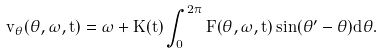<formula> <loc_0><loc_0><loc_500><loc_500>v _ { \theta } ( \theta , \omega , t ) = \omega + K ( t ) \int _ { 0 } ^ { 2 \pi } F ( \theta , \omega , t ) \sin ( \theta ^ { \prime } - \theta ) d \theta .</formula> 